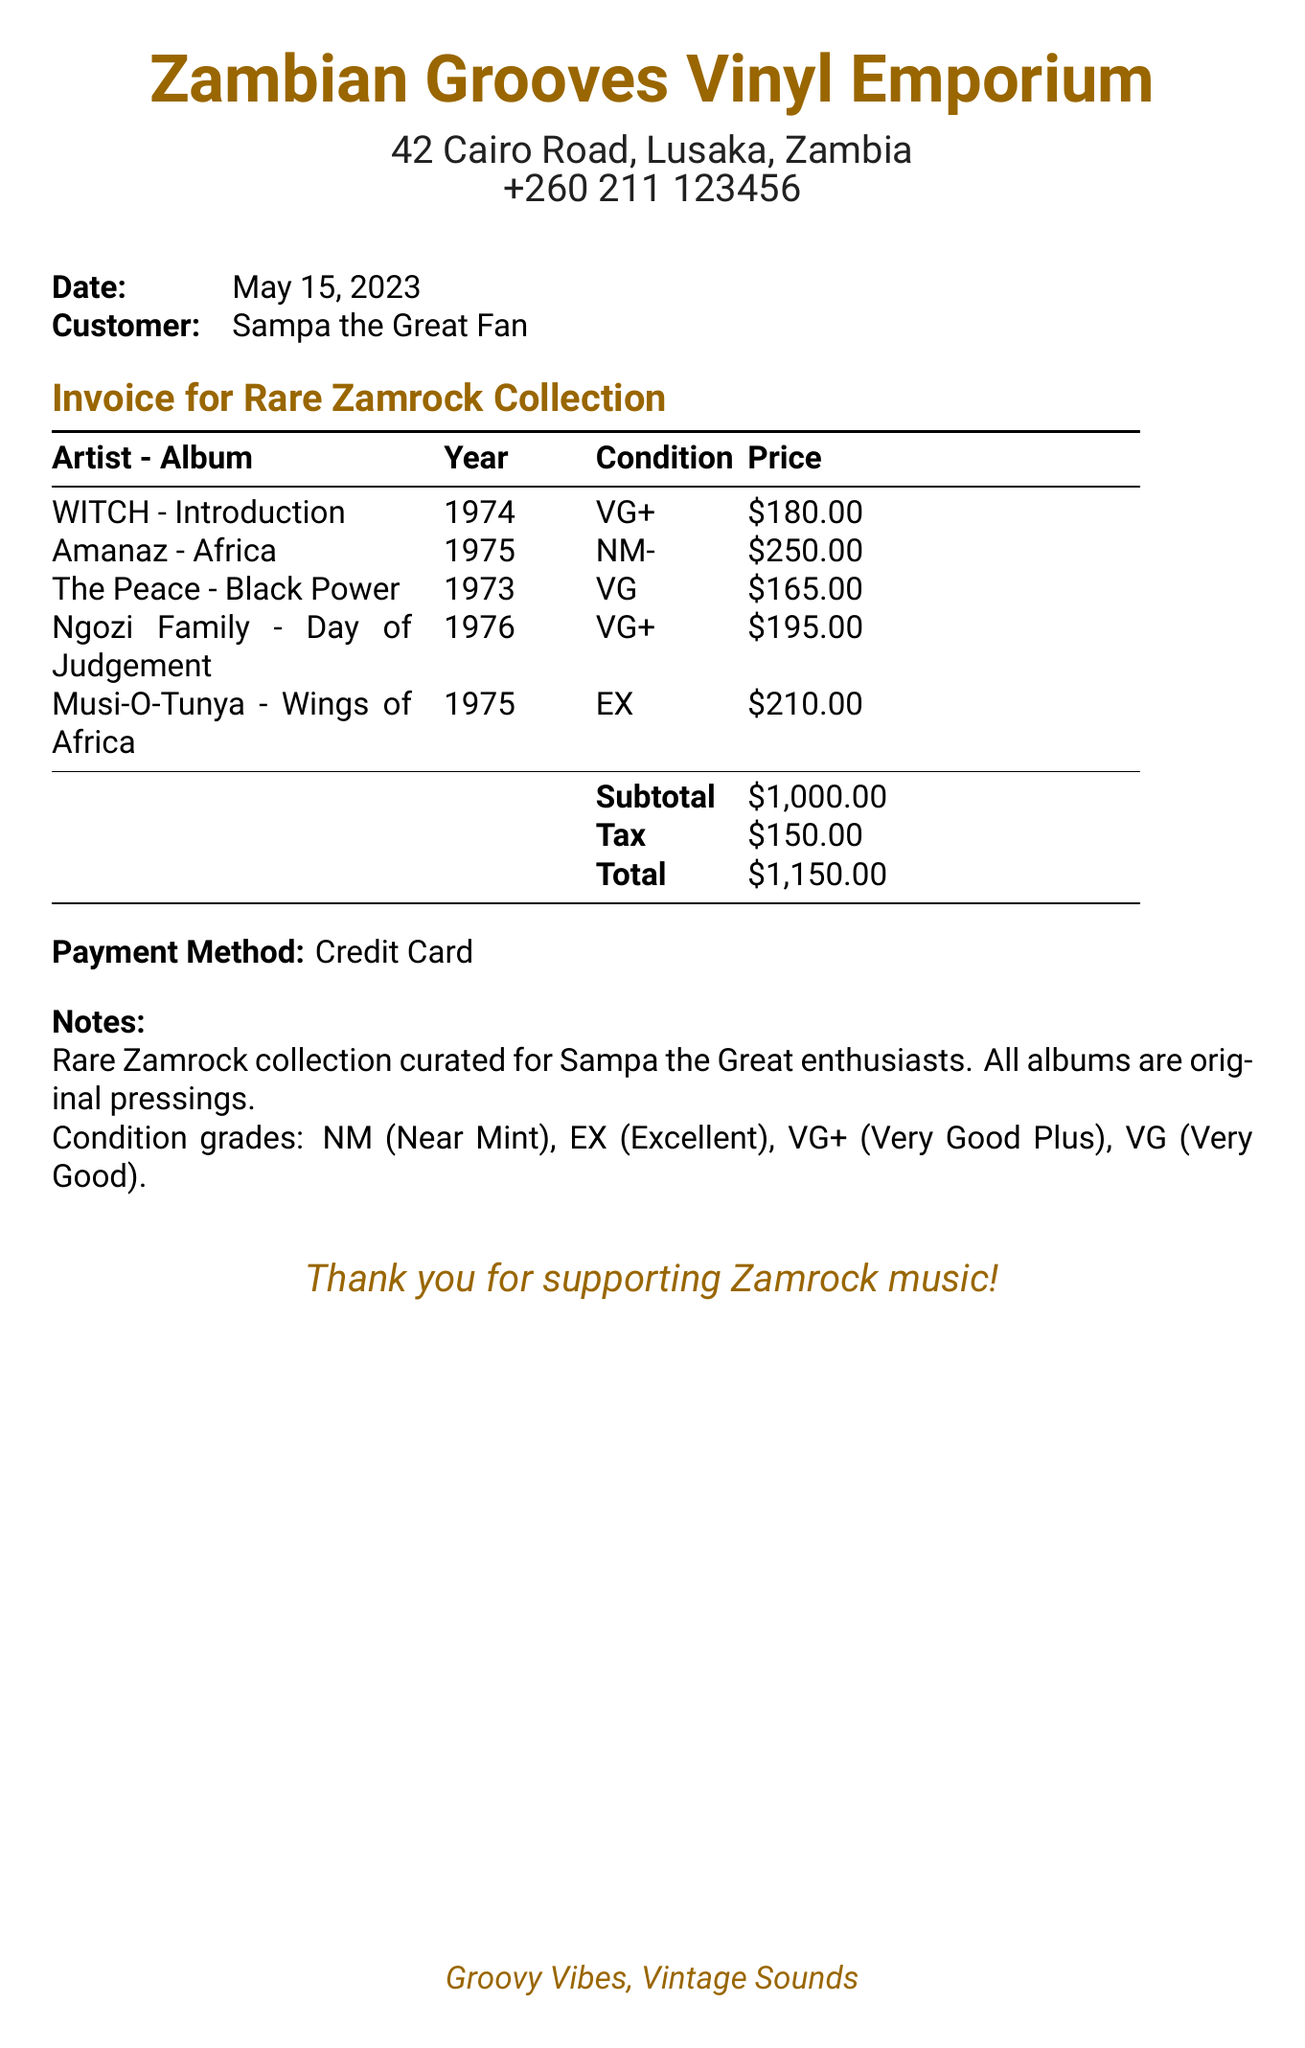What is the name of the store? The store name is indicated at the top of the document.
Answer: Zambian Grooves Vinyl Emporium Who is the customer? The customer's name is listed in the document.
Answer: Sampa the Great Fan What is the date of the invoice? The date is specified in the document's header section.
Answer: May 15, 2023 What is the condition of the album "Wings of Africa"? The condition is detailed next to each album title in the document.
Answer: EX How much was spent on the album "Africa"? The price for each album is noted in the invoice table.
Answer: $250.00 What is the subtotal amount? The subtotal is explicitly stated in the invoice right before the tax and total amounts.
Answer: $1,000.00 How much tax was applied? The tax amount is shown in the invoice under the subtotal.
Answer: $150.00 What is the total amount due? The total is given at the bottom of the invoice, summing up all charges.
Answer: $1,150.00 What payment method was used? The payment method is mentioned near the end of the document.
Answer: Credit Card What is noted about the collection? The notes provide context about the albums included in the invoice.
Answer: Rare Zamrock collection curated for Sampa the Great enthusiasts 